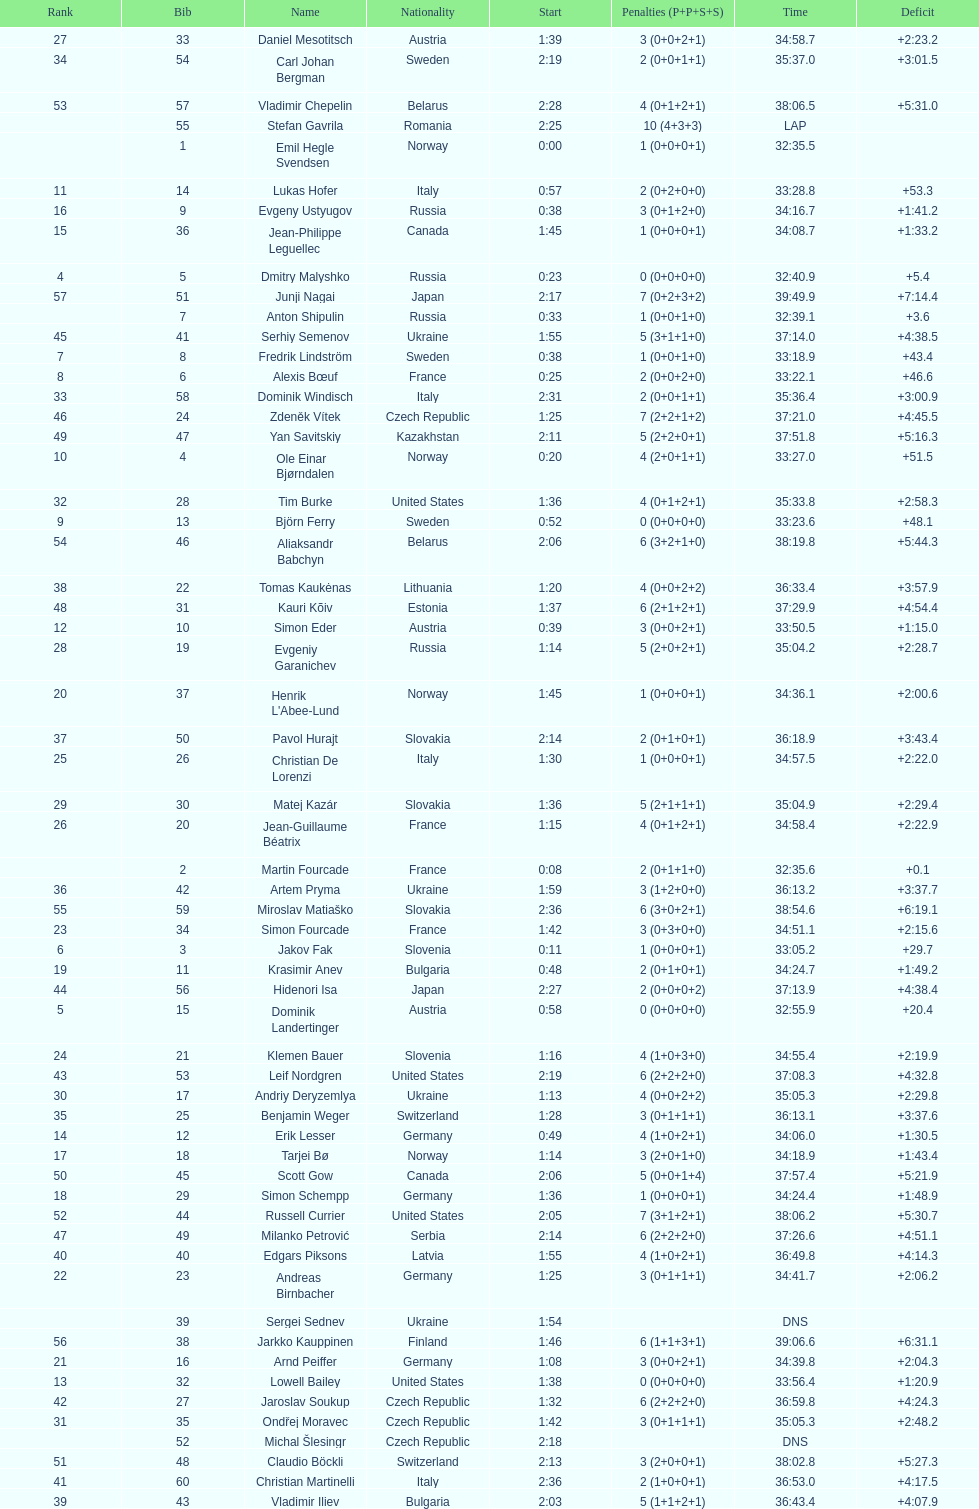What is the largest penalty? 10. 